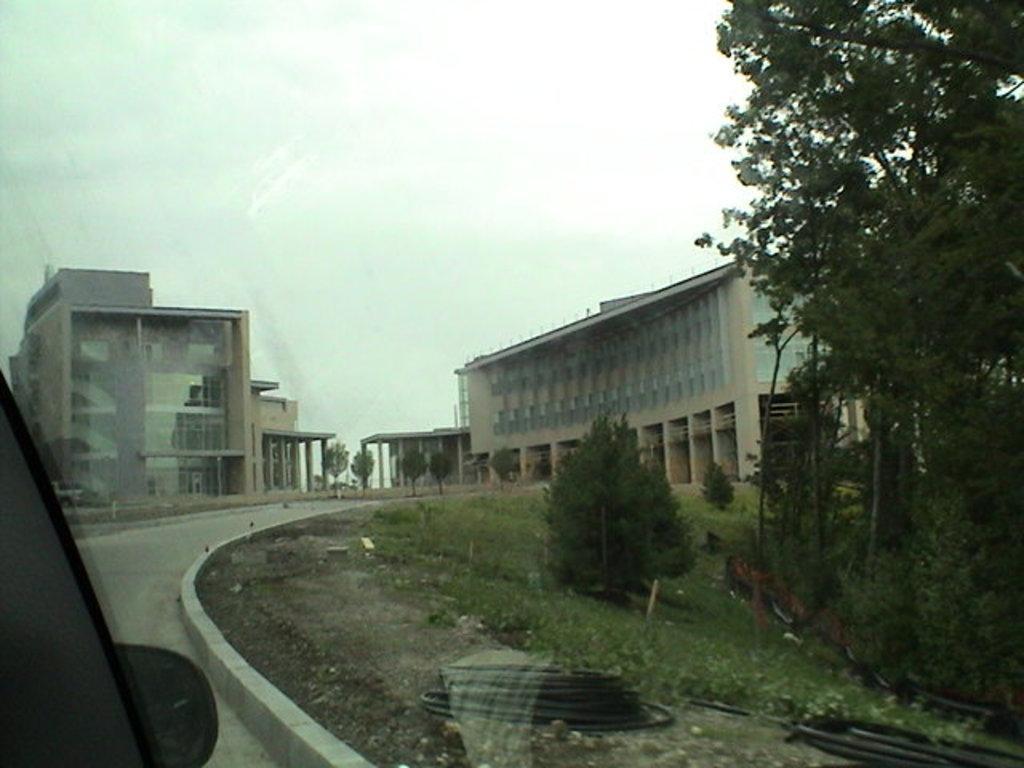In one or two sentences, can you explain what this image depicts? In this image we can see the buildings, trees, plants, grass and also the road. We can also see some other objects. On the left we can see the vehicle. 